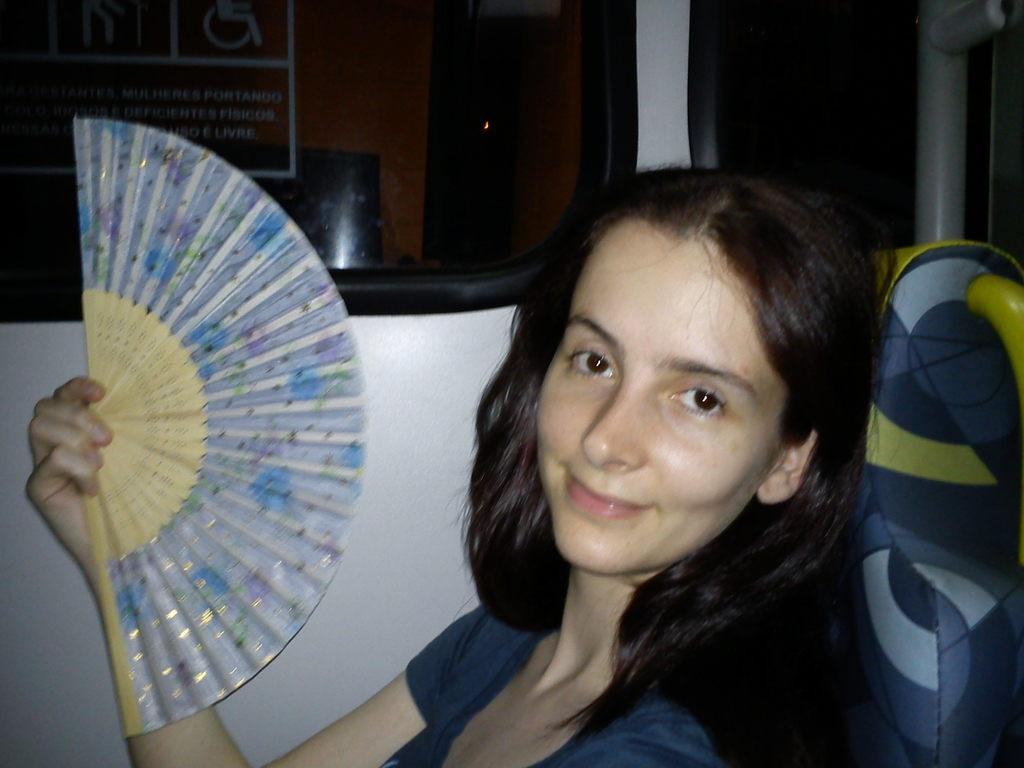Who is present in the image? There is a woman in the image. What is the woman holding in the image? The woman is holding a paper fan. What is the woman's position in the image? The woman is sitting on a seat. What can be seen through the window in the image? The window appears to be from a train, and it shows the passing scenery. What is visible in the background of the image? There is a shed visible in the background of the image. How many clocks are present in the image? There are no clocks visible in the image. Does the existence of the shed in the background prove the existence of a parallel universe? The presence of a shed in the background does not prove the existence of a parallel universe; it is simply a structure visible in the image. 